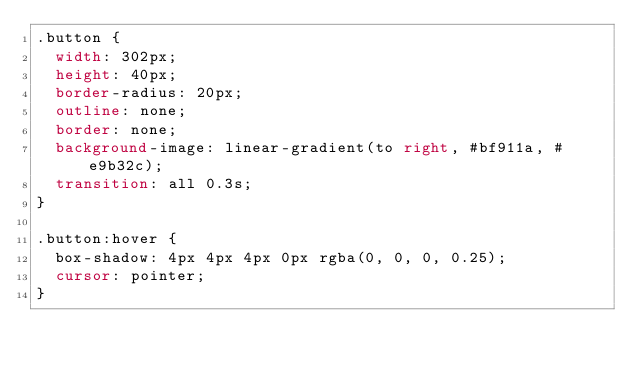Convert code to text. <code><loc_0><loc_0><loc_500><loc_500><_CSS_>.button {
  width: 302px;
  height: 40px;
  border-radius: 20px;
  outline: none;
  border: none;
  background-image: linear-gradient(to right, #bf911a, #e9b32c);
  transition: all 0.3s;
}

.button:hover {
  box-shadow: 4px 4px 4px 0px rgba(0, 0, 0, 0.25);
  cursor: pointer;
}
</code> 